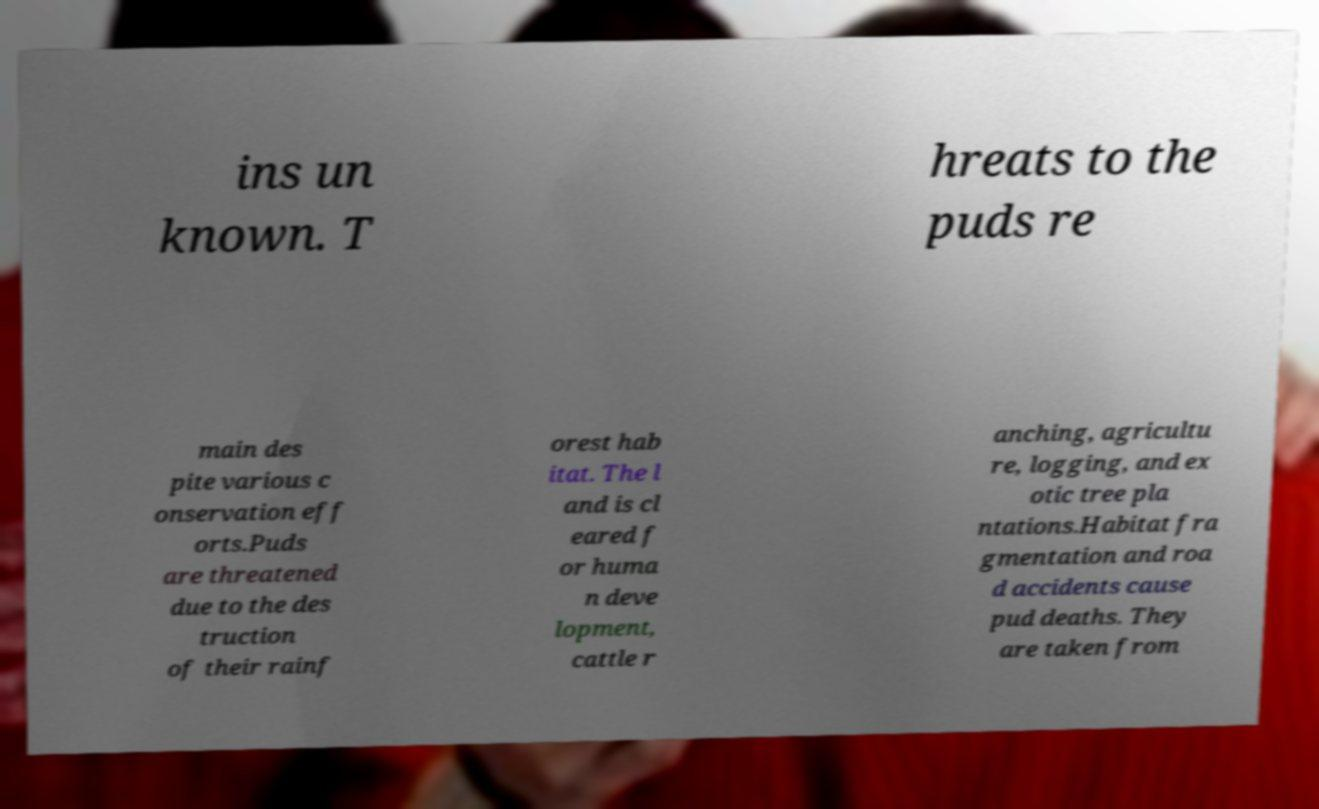Please read and relay the text visible in this image. What does it say? ins un known. T hreats to the puds re main des pite various c onservation eff orts.Puds are threatened due to the des truction of their rainf orest hab itat. The l and is cl eared f or huma n deve lopment, cattle r anching, agricultu re, logging, and ex otic tree pla ntations.Habitat fra gmentation and roa d accidents cause pud deaths. They are taken from 